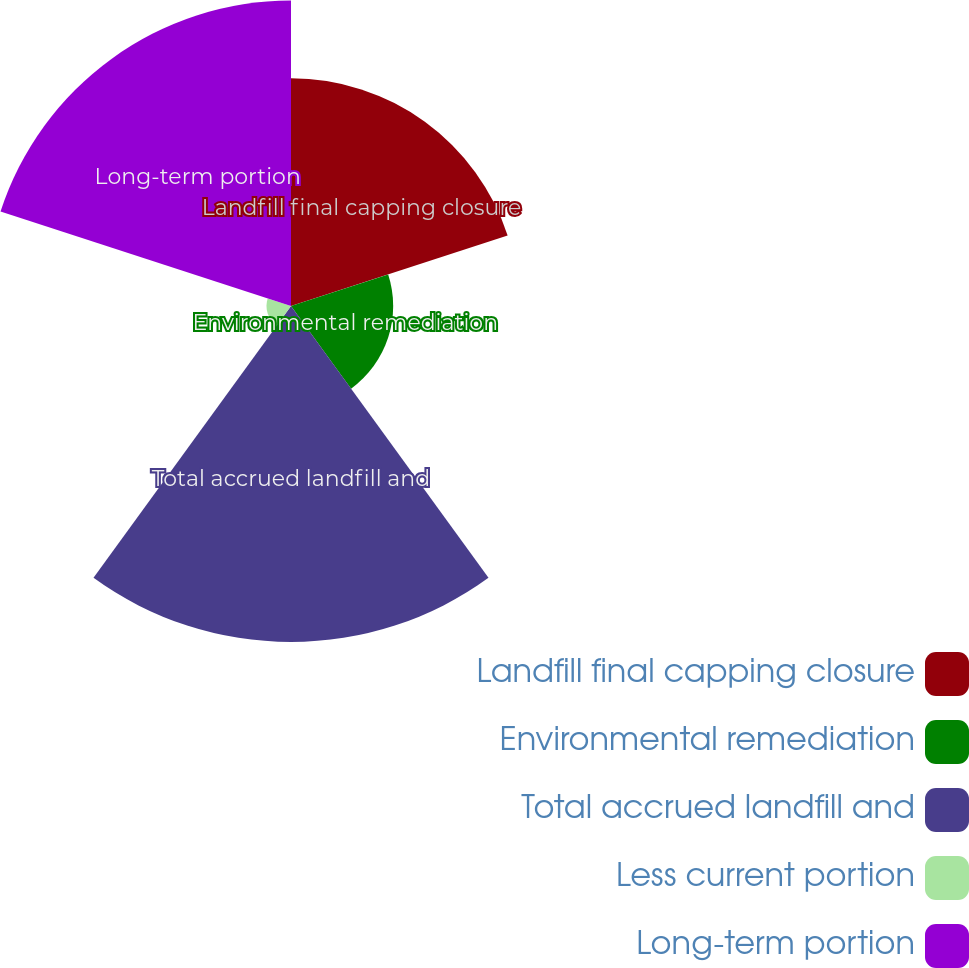Convert chart to OTSL. <chart><loc_0><loc_0><loc_500><loc_500><pie_chart><fcel>Landfill final capping closure<fcel>Environmental remediation<fcel>Total accrued landfill and<fcel>Less current portion<fcel>Long-term portion<nl><fcel>22.87%<fcel>10.26%<fcel>33.74%<fcel>2.46%<fcel>30.67%<nl></chart> 